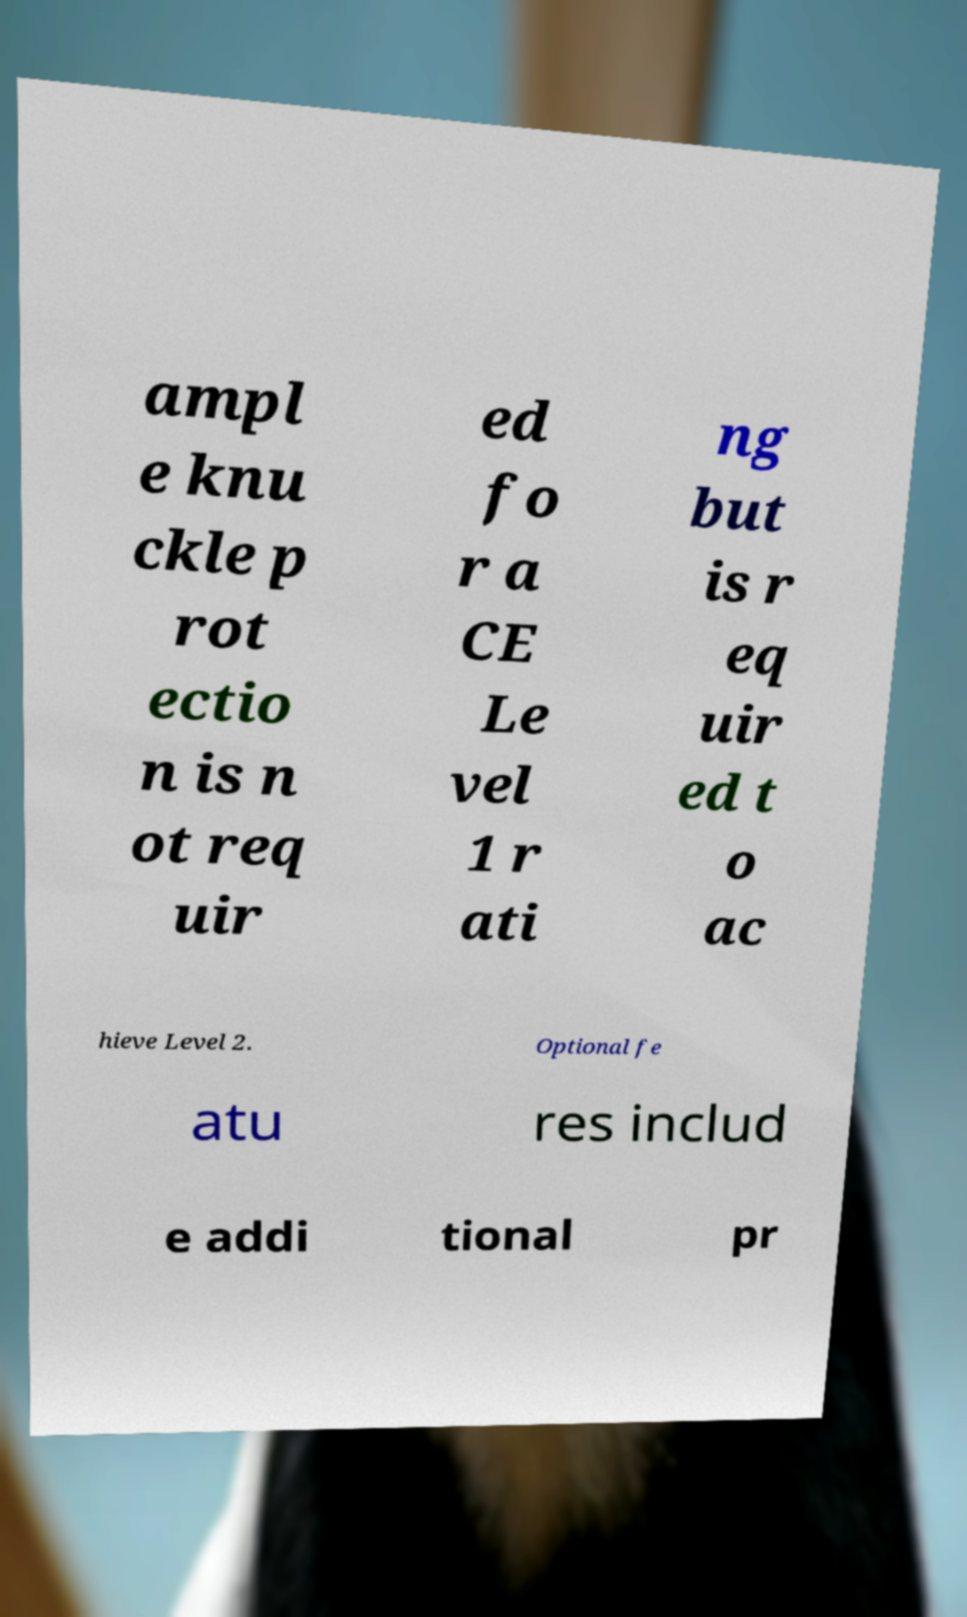Please identify and transcribe the text found in this image. ampl e knu ckle p rot ectio n is n ot req uir ed fo r a CE Le vel 1 r ati ng but is r eq uir ed t o ac hieve Level 2. Optional fe atu res includ e addi tional pr 